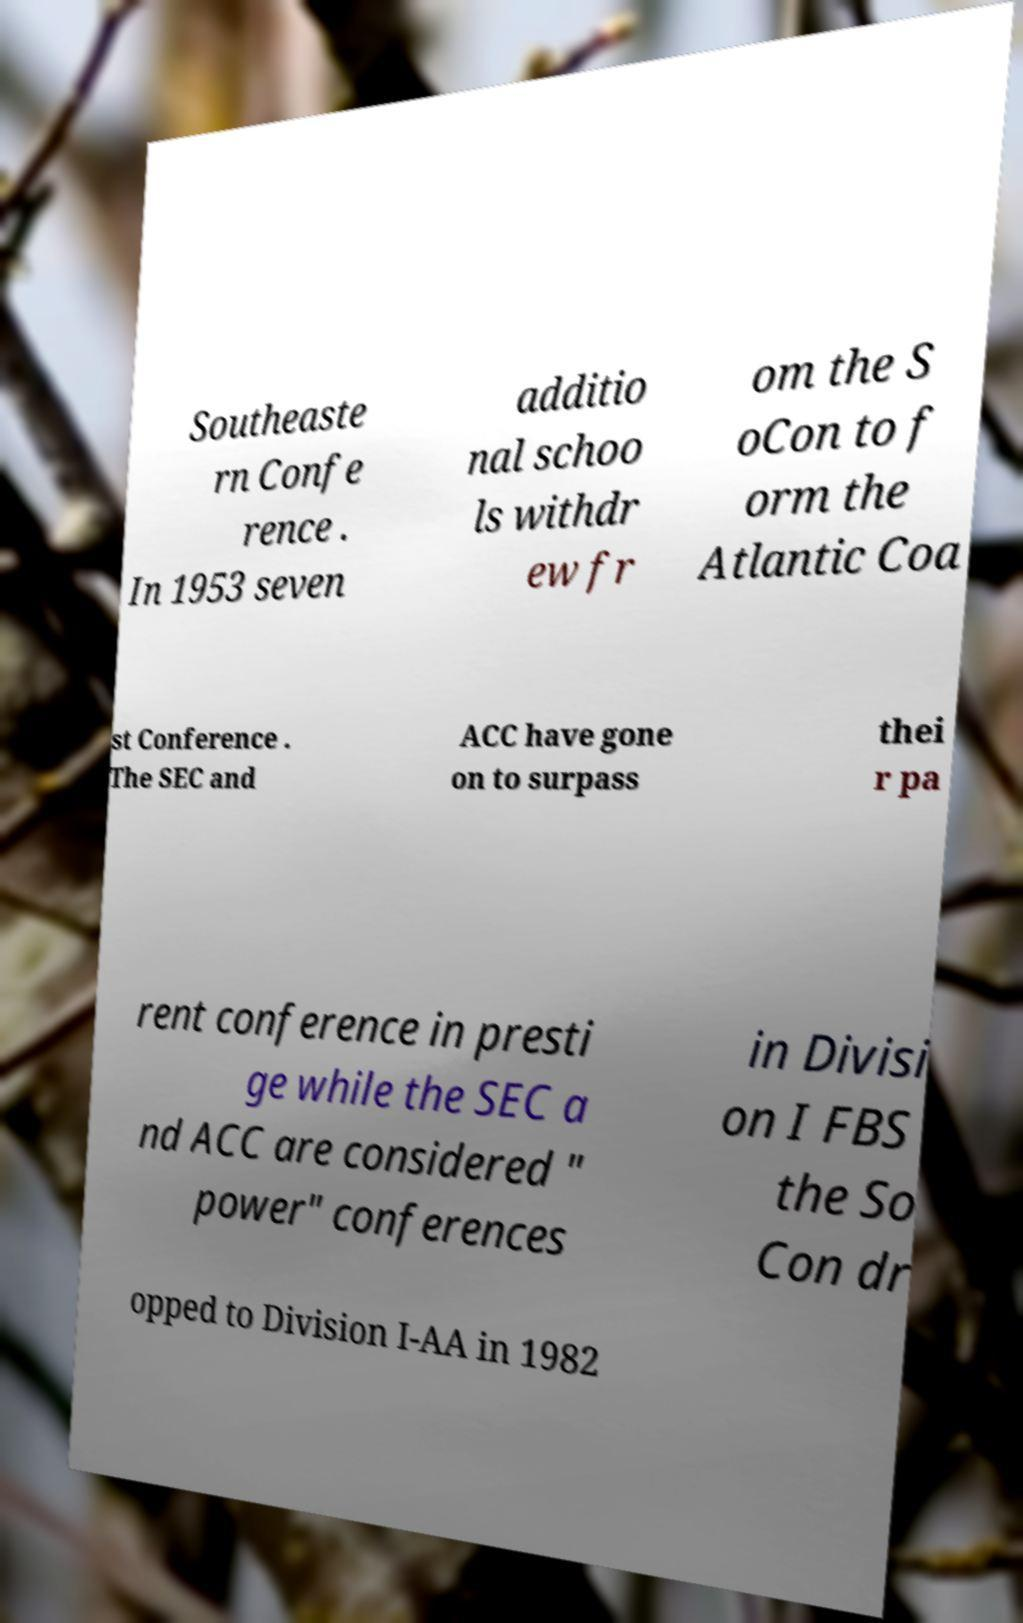For documentation purposes, I need the text within this image transcribed. Could you provide that? Southeaste rn Confe rence . In 1953 seven additio nal schoo ls withdr ew fr om the S oCon to f orm the Atlantic Coa st Conference . The SEC and ACC have gone on to surpass thei r pa rent conference in presti ge while the SEC a nd ACC are considered " power" conferences in Divisi on I FBS the So Con dr opped to Division I-AA in 1982 